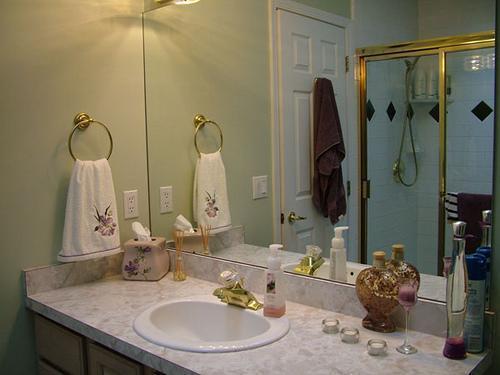How many towels are shown?
Give a very brief answer. 2. How many bottles are in the photo?
Give a very brief answer. 2. How many benches are there?
Give a very brief answer. 0. 